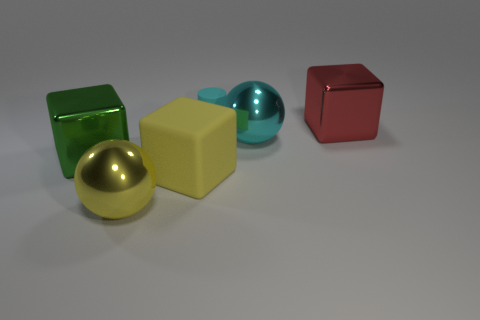Subtract all purple spheres. Subtract all gray cubes. How many spheres are left? 2 Add 3 cylinders. How many objects exist? 9 Subtract all spheres. How many objects are left? 4 Subtract all tiny cyan metallic blocks. Subtract all red blocks. How many objects are left? 5 Add 4 green metallic things. How many green metallic things are left? 5 Add 1 large yellow rubber blocks. How many large yellow rubber blocks exist? 2 Subtract 0 purple cubes. How many objects are left? 6 